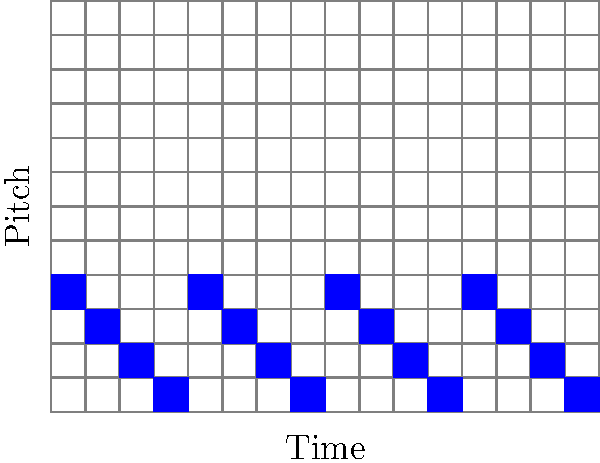In this piano roll representation of a Dardust composition, a fractal-like pattern emerges. If we consider each 4x4 block as a unit, how many times does this unit repeat itself horizontally across the entire 4x16 grid? To solve this problem, we need to follow these steps:

1. Identify the basic unit:
   The basic unit is a 4x4 block of the pattern.

2. Analyze the pattern:
   Looking at the image, we can see that the pattern consists of diagonal lines moving from bottom-left to top-right.

3. Count the repetitions:
   - The entire grid is 4 rows high and 16 columns wide.
   - Each basic unit is 4 columns wide.
   - To find the number of repetitions, we divide the total width by the width of one unit:
     $$\text{Number of repetitions} = \frac{\text{Total width}}{\text{Unit width}} = \frac{16}{4} = 4$$

4. Verify visually:
   We can confirm this by looking at the image and seeing that the same 4x4 pattern indeed repeats 4 times horizontally.

This fractal-like structure is characteristic of Dardust's minimalist approach, often incorporating repetitive patterns that create a hypnotic effect in his music.
Answer: 4 